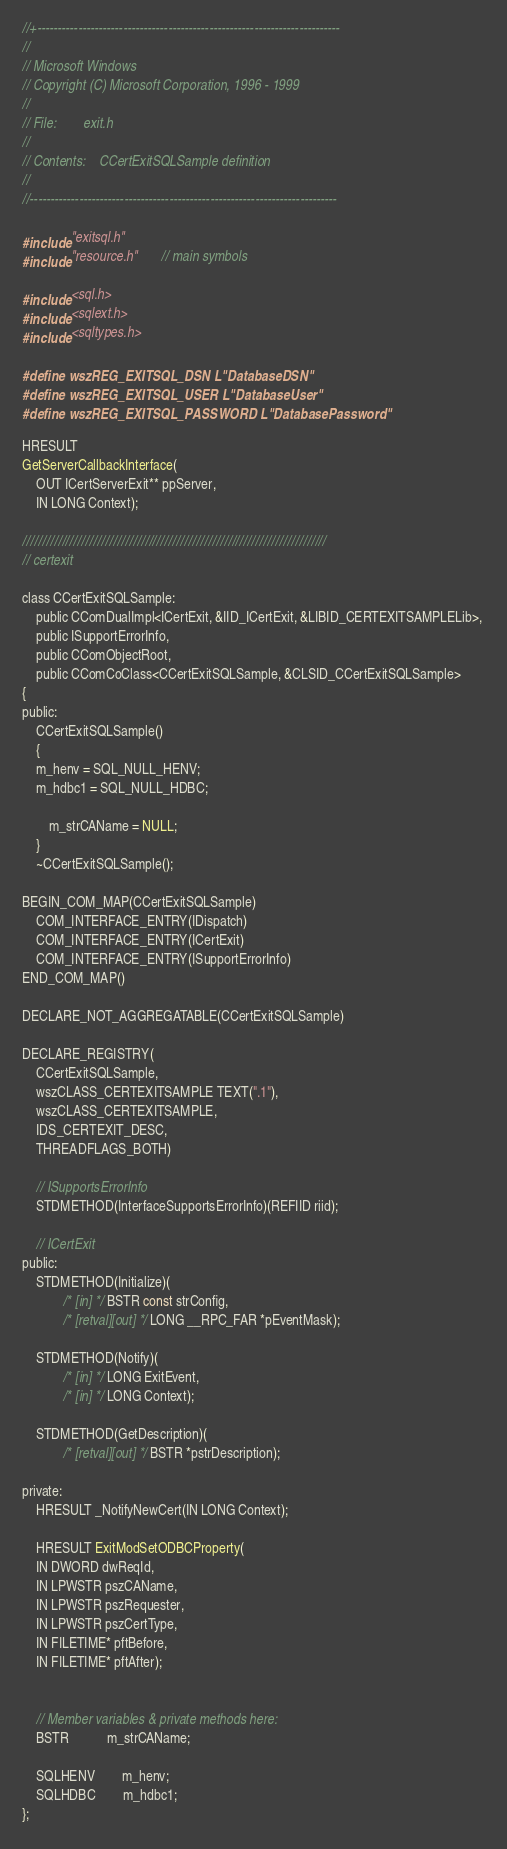Convert code to text. <code><loc_0><loc_0><loc_500><loc_500><_C_>//+--------------------------------------------------------------------------
//
// Microsoft Windows
// Copyright (C) Microsoft Corporation, 1996 - 1999
//
// File:        exit.h
//
// Contents:    CCertExitSQLSample definition
//
//---------------------------------------------------------------------------

#include "exitsql.h"
#include "resource.h"       // main symbols

#include <sql.h>
#include <sqlext.h>
#include <sqltypes.h>

#define wszREG_EXITSQL_DSN L"DatabaseDSN"
#define wszREG_EXITSQL_USER L"DatabaseUser"
#define wszREG_EXITSQL_PASSWORD L"DatabasePassword"

HRESULT
GetServerCallbackInterface(
    OUT ICertServerExit** ppServer,
    IN LONG Context);

/////////////////////////////////////////////////////////////////////////////
// certexit

class CCertExitSQLSample: 
    public CComDualImpl<ICertExit, &IID_ICertExit, &LIBID_CERTEXITSAMPLELib>, 
    public ISupportErrorInfo,
    public CComObjectRoot,
    public CComCoClass<CCertExitSQLSample, &CLSID_CCertExitSQLSample>
{
public:
    CCertExitSQLSample() 
    { 
	m_henv = SQL_NULL_HENV;
	m_hdbc1 = SQL_NULL_HDBC;   

        m_strCAName = NULL;
    }
    ~CCertExitSQLSample();

BEGIN_COM_MAP(CCertExitSQLSample)
    COM_INTERFACE_ENTRY(IDispatch)
    COM_INTERFACE_ENTRY(ICertExit)
    COM_INTERFACE_ENTRY(ISupportErrorInfo)
END_COM_MAP()

DECLARE_NOT_AGGREGATABLE(CCertExitSQLSample) 

DECLARE_REGISTRY(
    CCertExitSQLSample,
    wszCLASS_CERTEXITSAMPLE TEXT(".1"),
    wszCLASS_CERTEXITSAMPLE,
    IDS_CERTEXIT_DESC,
    THREADFLAGS_BOTH)

    // ISupportsErrorInfo
    STDMETHOD(InterfaceSupportsErrorInfo)(REFIID riid);

    // ICertExit
public:
    STDMETHOD(Initialize)( 
            /* [in] */ BSTR const strConfig,
            /* [retval][out] */ LONG __RPC_FAR *pEventMask);

    STDMETHOD(Notify)(
            /* [in] */ LONG ExitEvent,
            /* [in] */ LONG Context);

    STDMETHOD(GetDescription)( 
            /* [retval][out] */ BSTR *pstrDescription);

private:
    HRESULT _NotifyNewCert(IN LONG Context);

	HRESULT ExitModSetODBCProperty(
	IN DWORD dwReqId,
	IN LPWSTR pszCAName,
	IN LPWSTR pszRequester,
	IN LPWSTR pszCertType,
	IN FILETIME* pftBefore,
	IN FILETIME* pftAfter);


    // Member variables & private methods here:
    BSTR           m_strCAName;

	SQLHENV        m_henv;
	SQLHDBC        m_hdbc1;     
};

</code> 